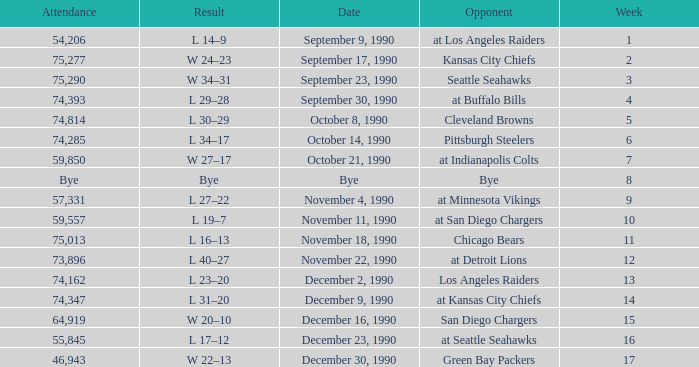What day was the attendance 74,285? October 14, 1990. 